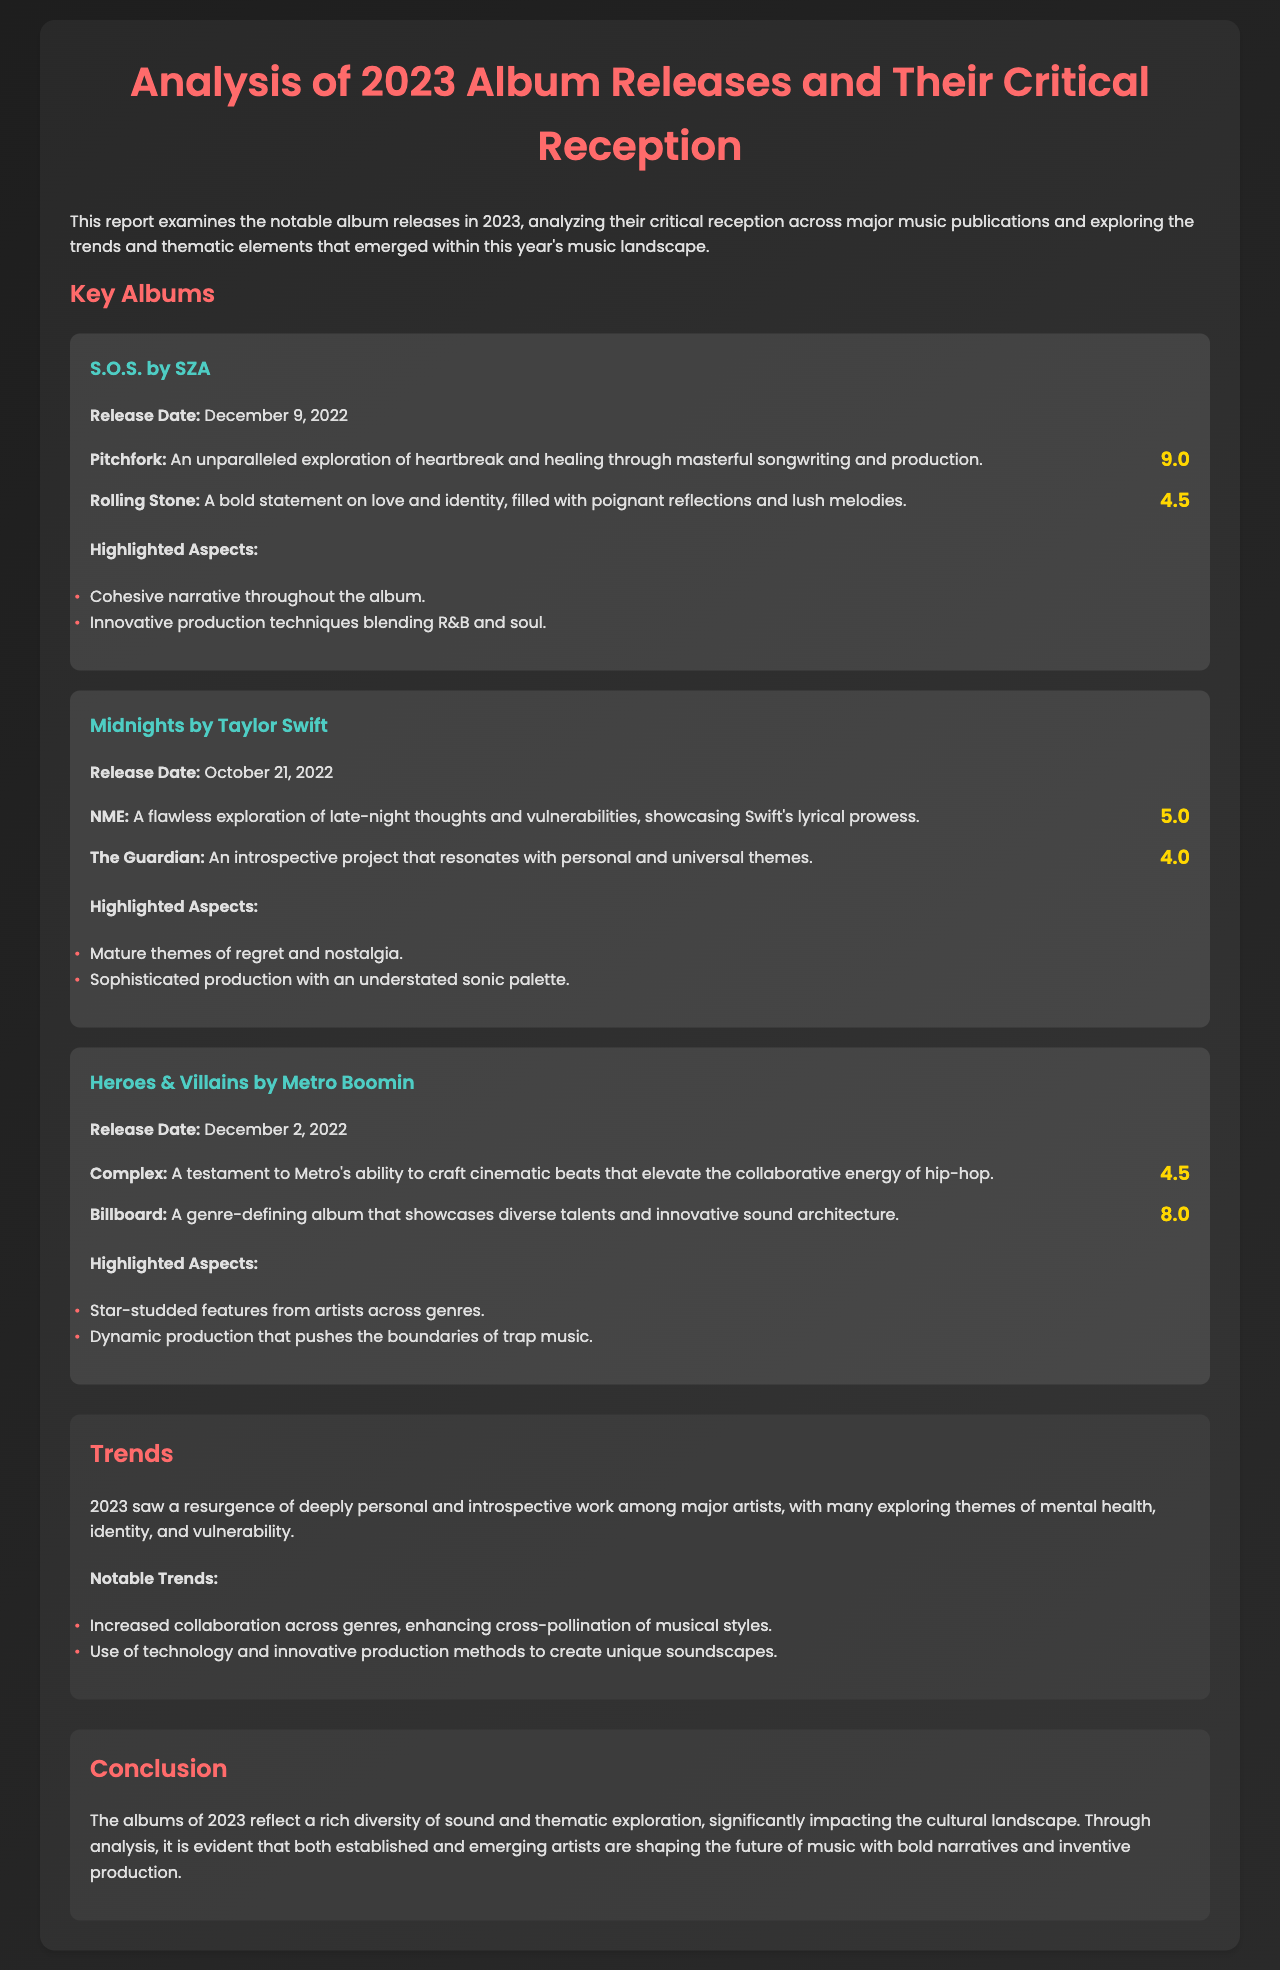what is the title of the report? The title of the report is provided at the beginning of the document as "Analysis of 2023 Album Releases and Their Critical Reception."
Answer: Analysis of 2023 Album Releases and Their Critical Reception which album was released by SZA? The album released by SZA mentioned in the document is "S.O.S."
Answer: S.O.S what was the rating given by Pitchfork for "Midnights"? The Pitchfork rating for "Midnights" is specified in the document as 5.0.
Answer: 5.0 what are two highlighted aspects of "Heroes & Villains"? The document lists two highlighted aspects of "Heroes & Villains," which are "Star-studded features from artists across genres" and "Dynamic production that pushes the boundaries of trap music."
Answer: Star-studded features from artists across genres; Dynamic production that pushes the boundaries of trap music which major trend is noted regarding album production in 2023? The document highlights a major trend where "Use of technology and innovative production methods to create unique soundscapes" is emphasized.
Answer: Use of technology and innovative production methods to create unique soundscapes how does the document characterize the album releases of 2023? The conclusion section of the document characterizes the album releases of 2023 as reflecting "a rich diversity of sound and thematic exploration."
Answer: a rich diversity of sound and thematic exploration 